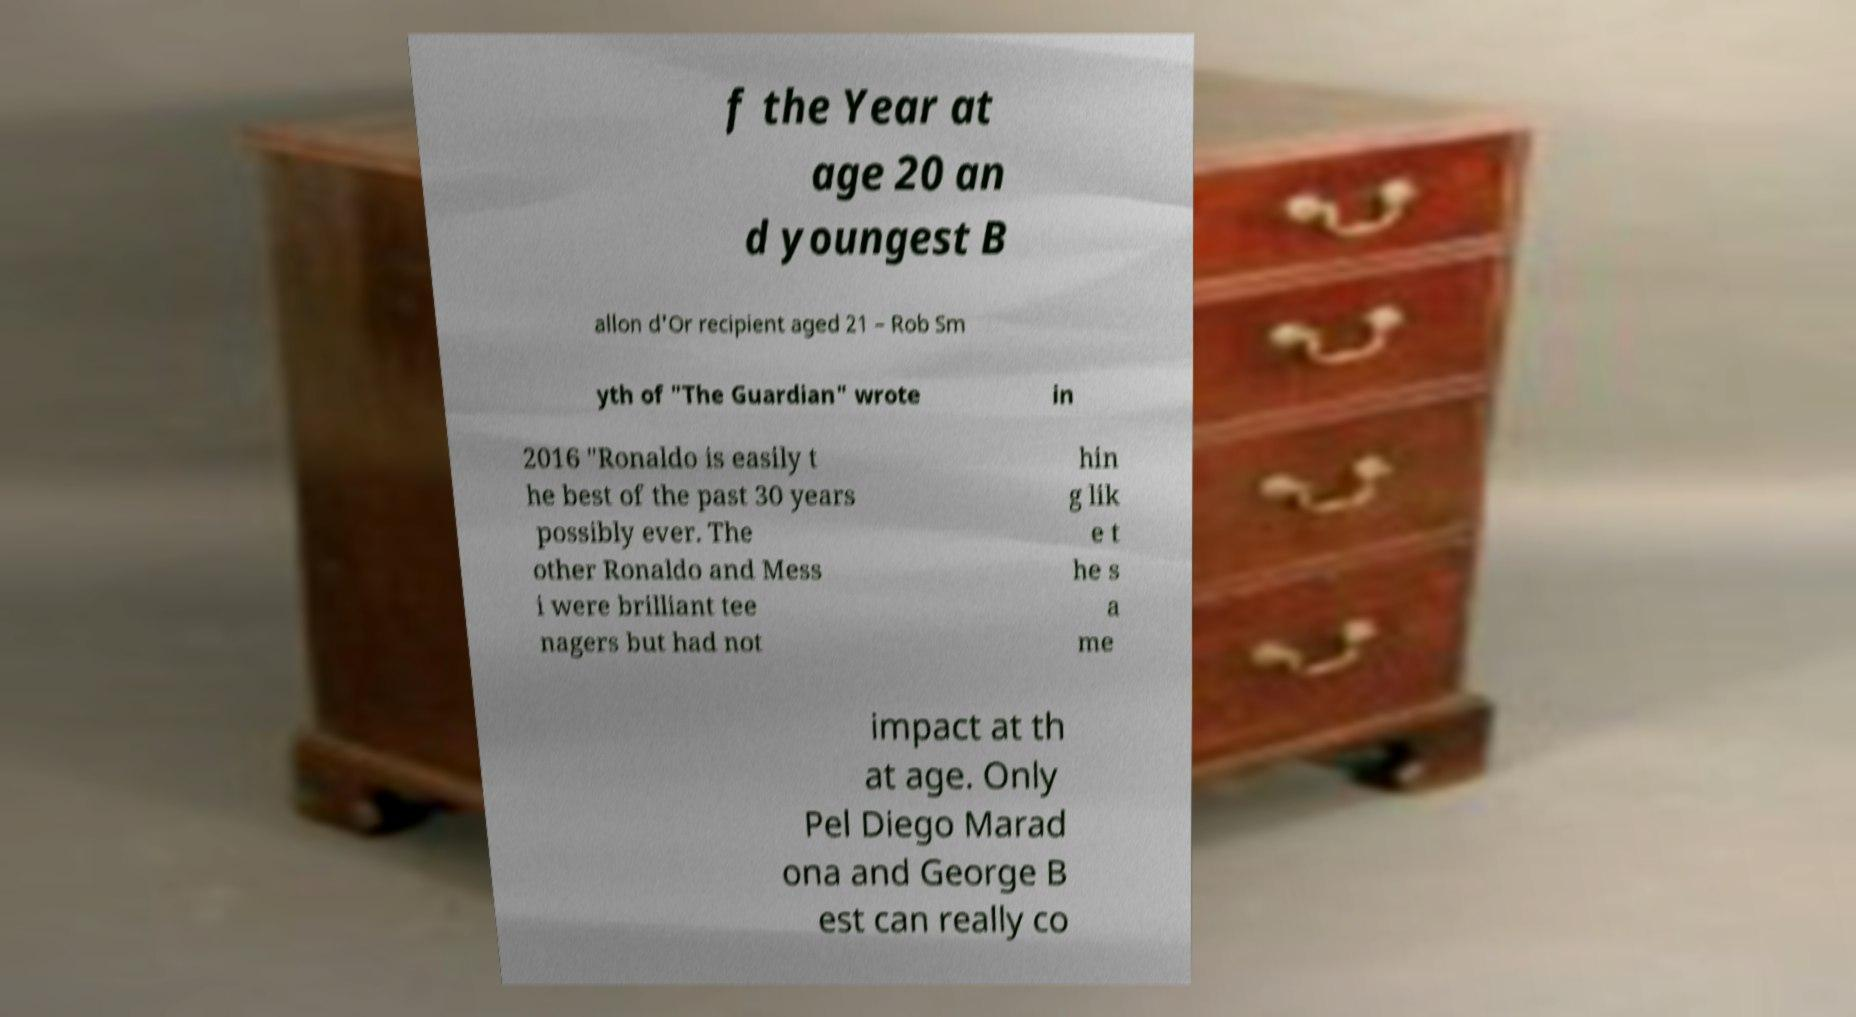Could you extract and type out the text from this image? f the Year at age 20 an d youngest B allon d'Or recipient aged 21 – Rob Sm yth of "The Guardian" wrote in 2016 "Ronaldo is easily t he best of the past 30 years possibly ever. The other Ronaldo and Mess i were brilliant tee nagers but had not hin g lik e t he s a me impact at th at age. Only Pel Diego Marad ona and George B est can really co 